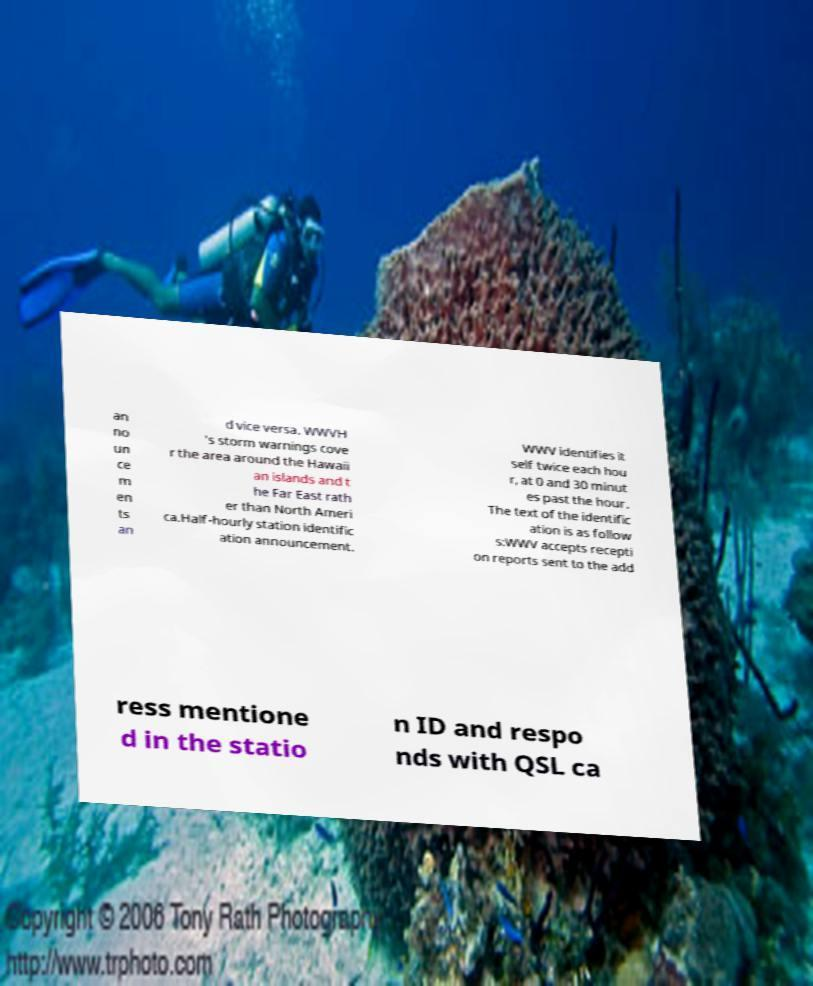Could you extract and type out the text from this image? an no un ce m en ts an d vice versa. WWVH 's storm warnings cove r the area around the Hawaii an islands and t he Far East rath er than North Ameri ca.Half-hourly station identific ation announcement. WWV identifies it self twice each hou r, at 0 and 30 minut es past the hour. The text of the identific ation is as follow s:WWV accepts recepti on reports sent to the add ress mentione d in the statio n ID and respo nds with QSL ca 